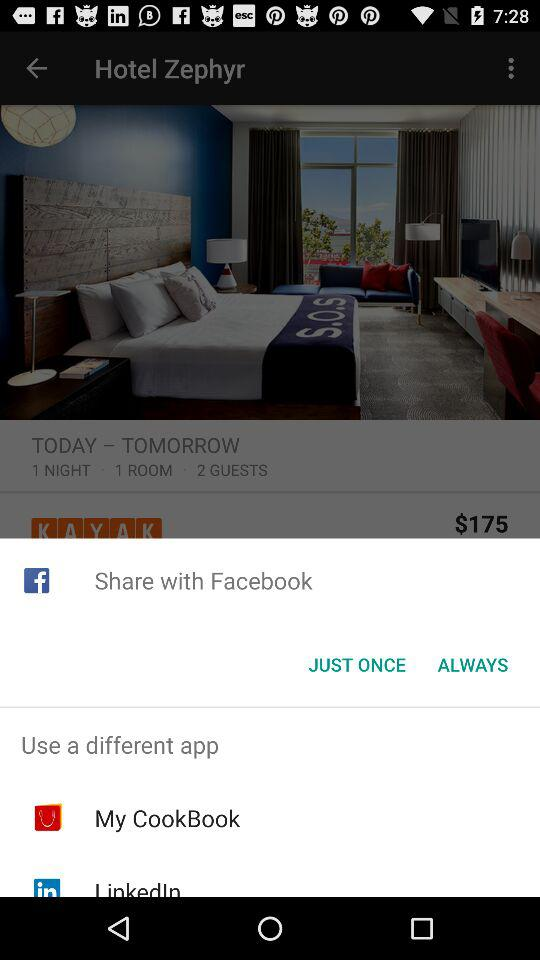Which application can we use for sharing? The applications that you can use for sharing are "Facebook", "My CookBook" and "LinkedIn". 